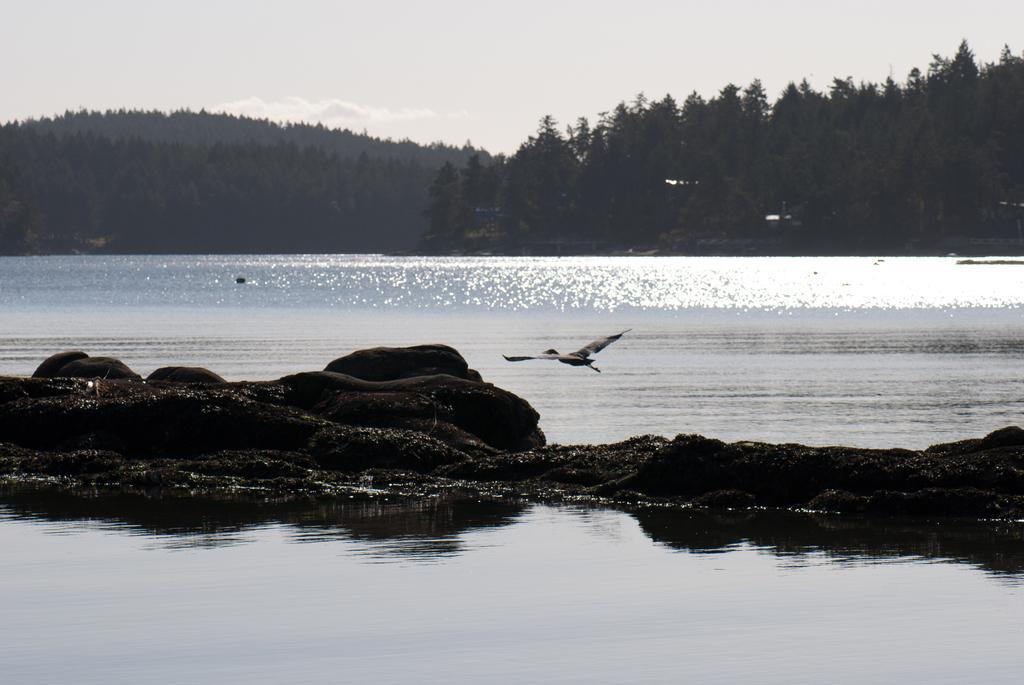Describe this image in one or two sentences. In this picture there is a bird which is flying in the air. On the left I can see big stones. In the center I can see the river. In the background I can see the mountain. At the top I can see the sky and clouds. 